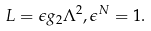<formula> <loc_0><loc_0><loc_500><loc_500>L = \epsilon g _ { 2 } \Lambda ^ { 2 } , \epsilon ^ { N } = 1 .</formula> 